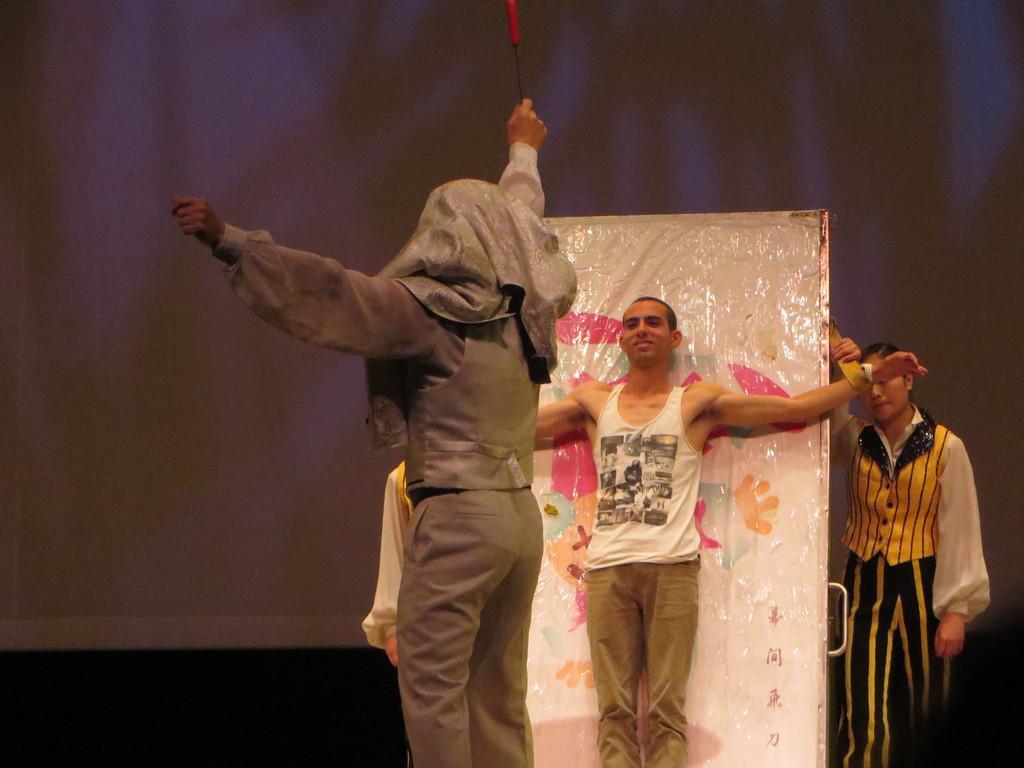Please provide a concise description of this image. In the center of the image there are persons. In the background of the image there is screen. 